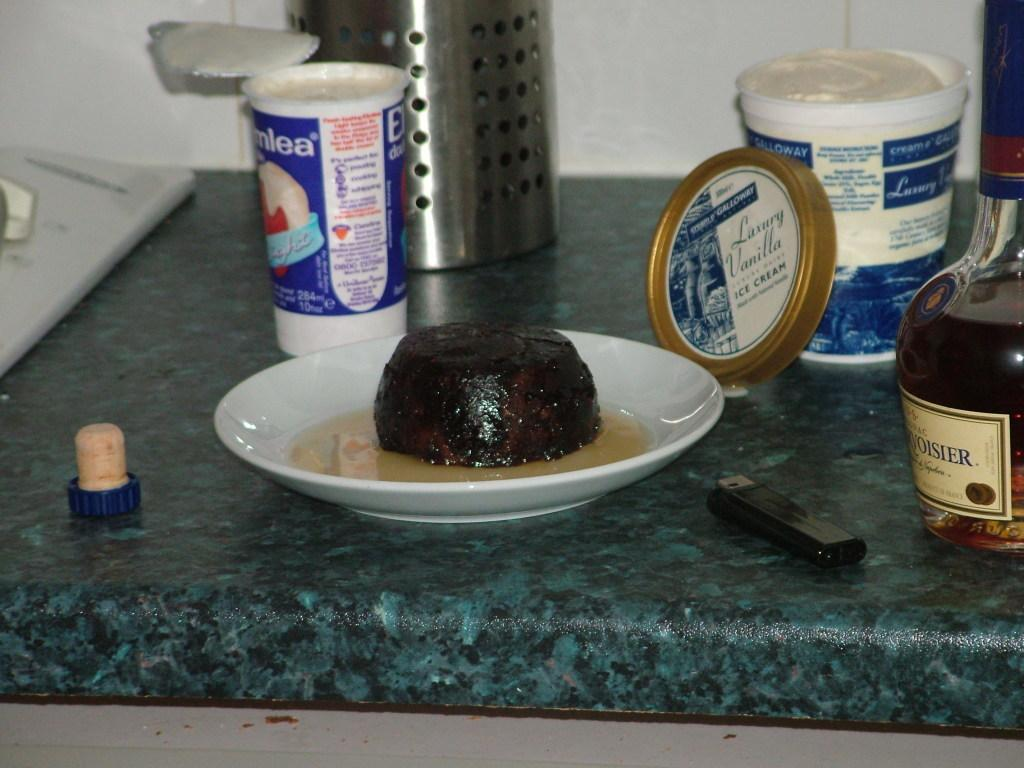<image>
Create a compact narrative representing the image presented. Food is on a plate next to an open container of Luxury Vanilla ice cream. 